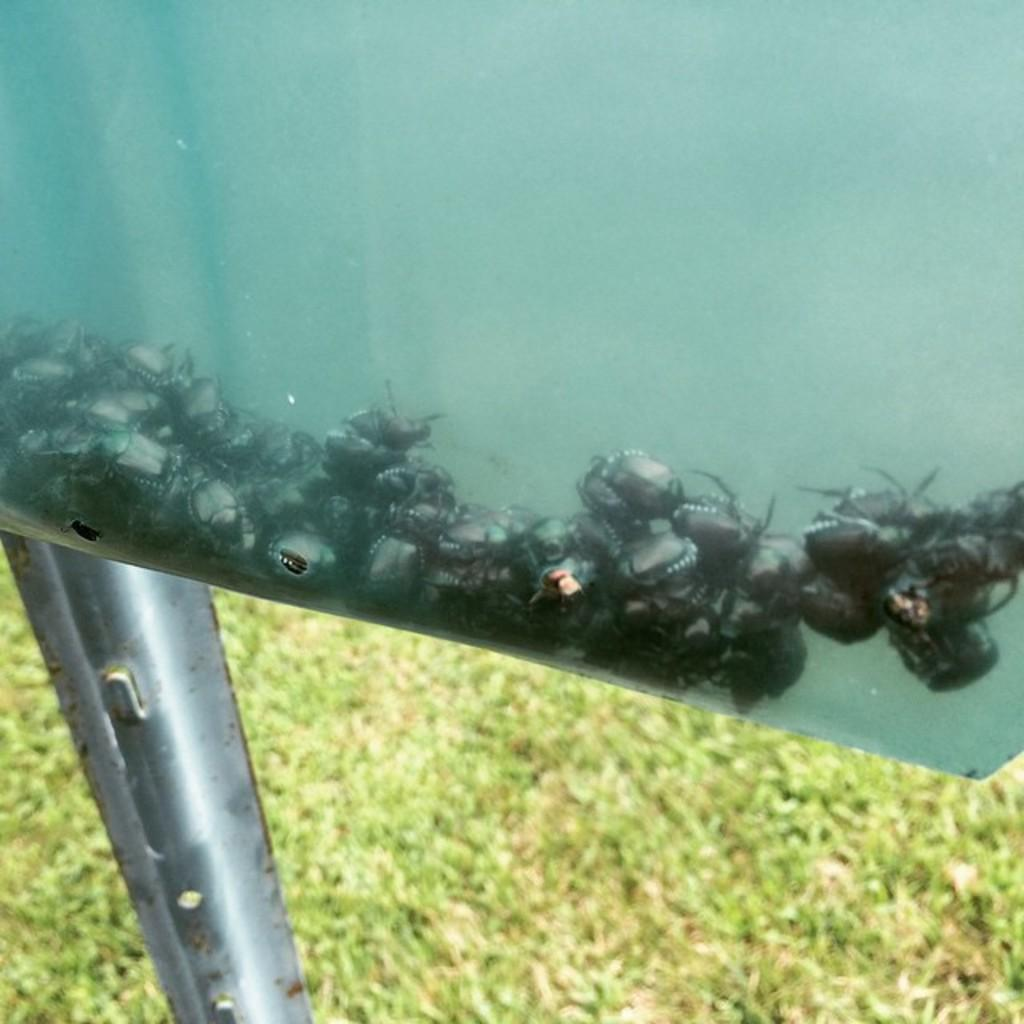What is the main object in the image? The image appears to show a glass box. What is inside the glass box? There are insects inside the glass box. What is supporting the glass box in the image? There is a metal stand under the glass box. What type of environment is visible at the bottom of the image? Grass is visible on the ground at the bottom of the image. What type of bun is being discussed by the insects inside the glass box? There is no indication of a bun or any discussion taking place in the image. The image shows insects inside a glass box, supported by a metal stand, with grass visible at the bottom. 